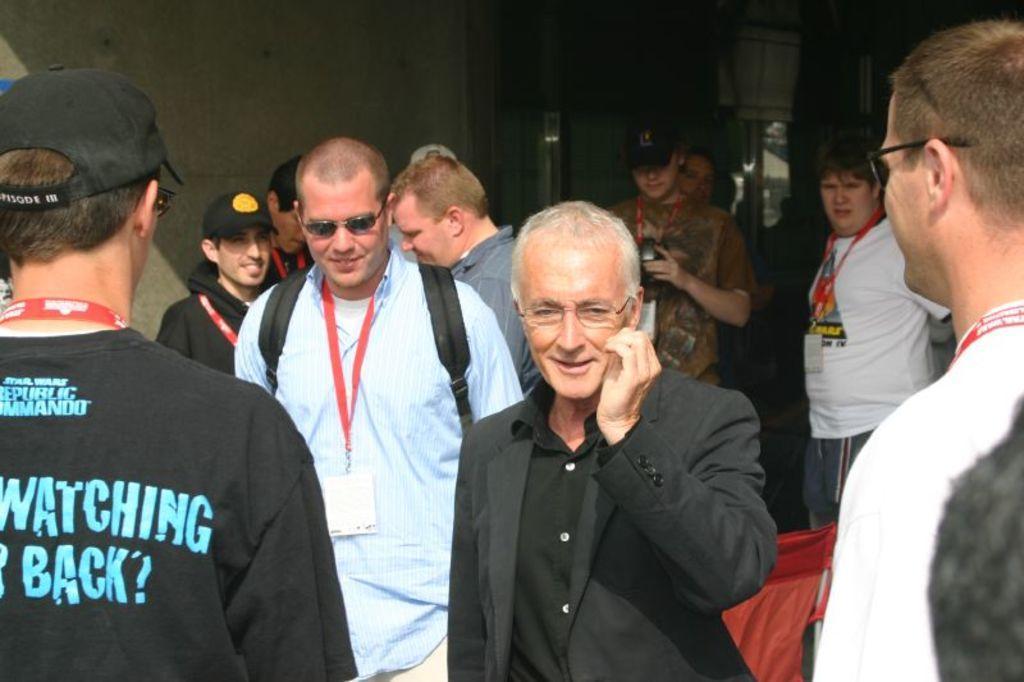Describe this image in one or two sentences. In this image we can see these people are walking on a road. The background of the image is dark where we can see the wall. 